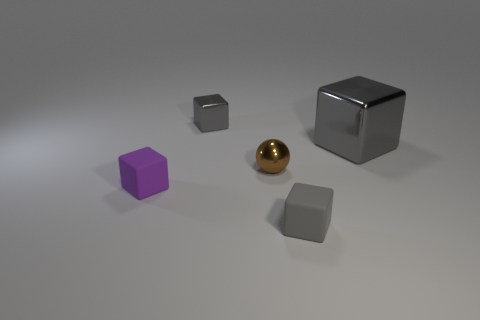How many gray cubes must be subtracted to get 1 gray cubes? 2 Add 4 tiny red rubber cylinders. How many objects exist? 9 Subtract all tiny gray matte cubes. How many cubes are left? 3 Subtract all gray cubes. How many cubes are left? 1 Add 2 small gray things. How many small gray things are left? 4 Add 1 purple rubber objects. How many purple rubber objects exist? 2 Subtract 0 green spheres. How many objects are left? 5 Subtract all blocks. How many objects are left? 1 Subtract all yellow cubes. Subtract all cyan cylinders. How many cubes are left? 4 Subtract all purple balls. How many gray cubes are left? 3 